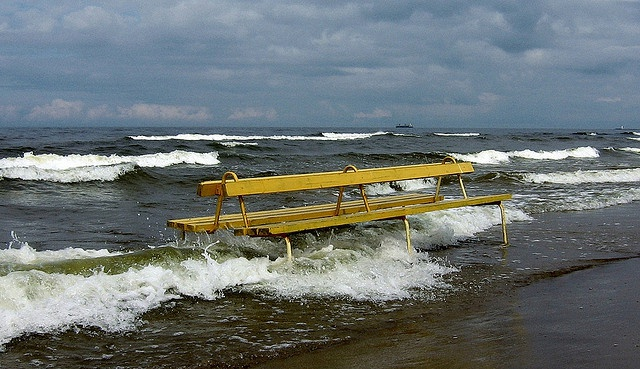Describe the objects in this image and their specific colors. I can see bench in darkgray, olive, black, orange, and gray tones, bench in darkgray, olive, black, gray, and maroon tones, and boat in darkgray, black, navy, and gray tones in this image. 